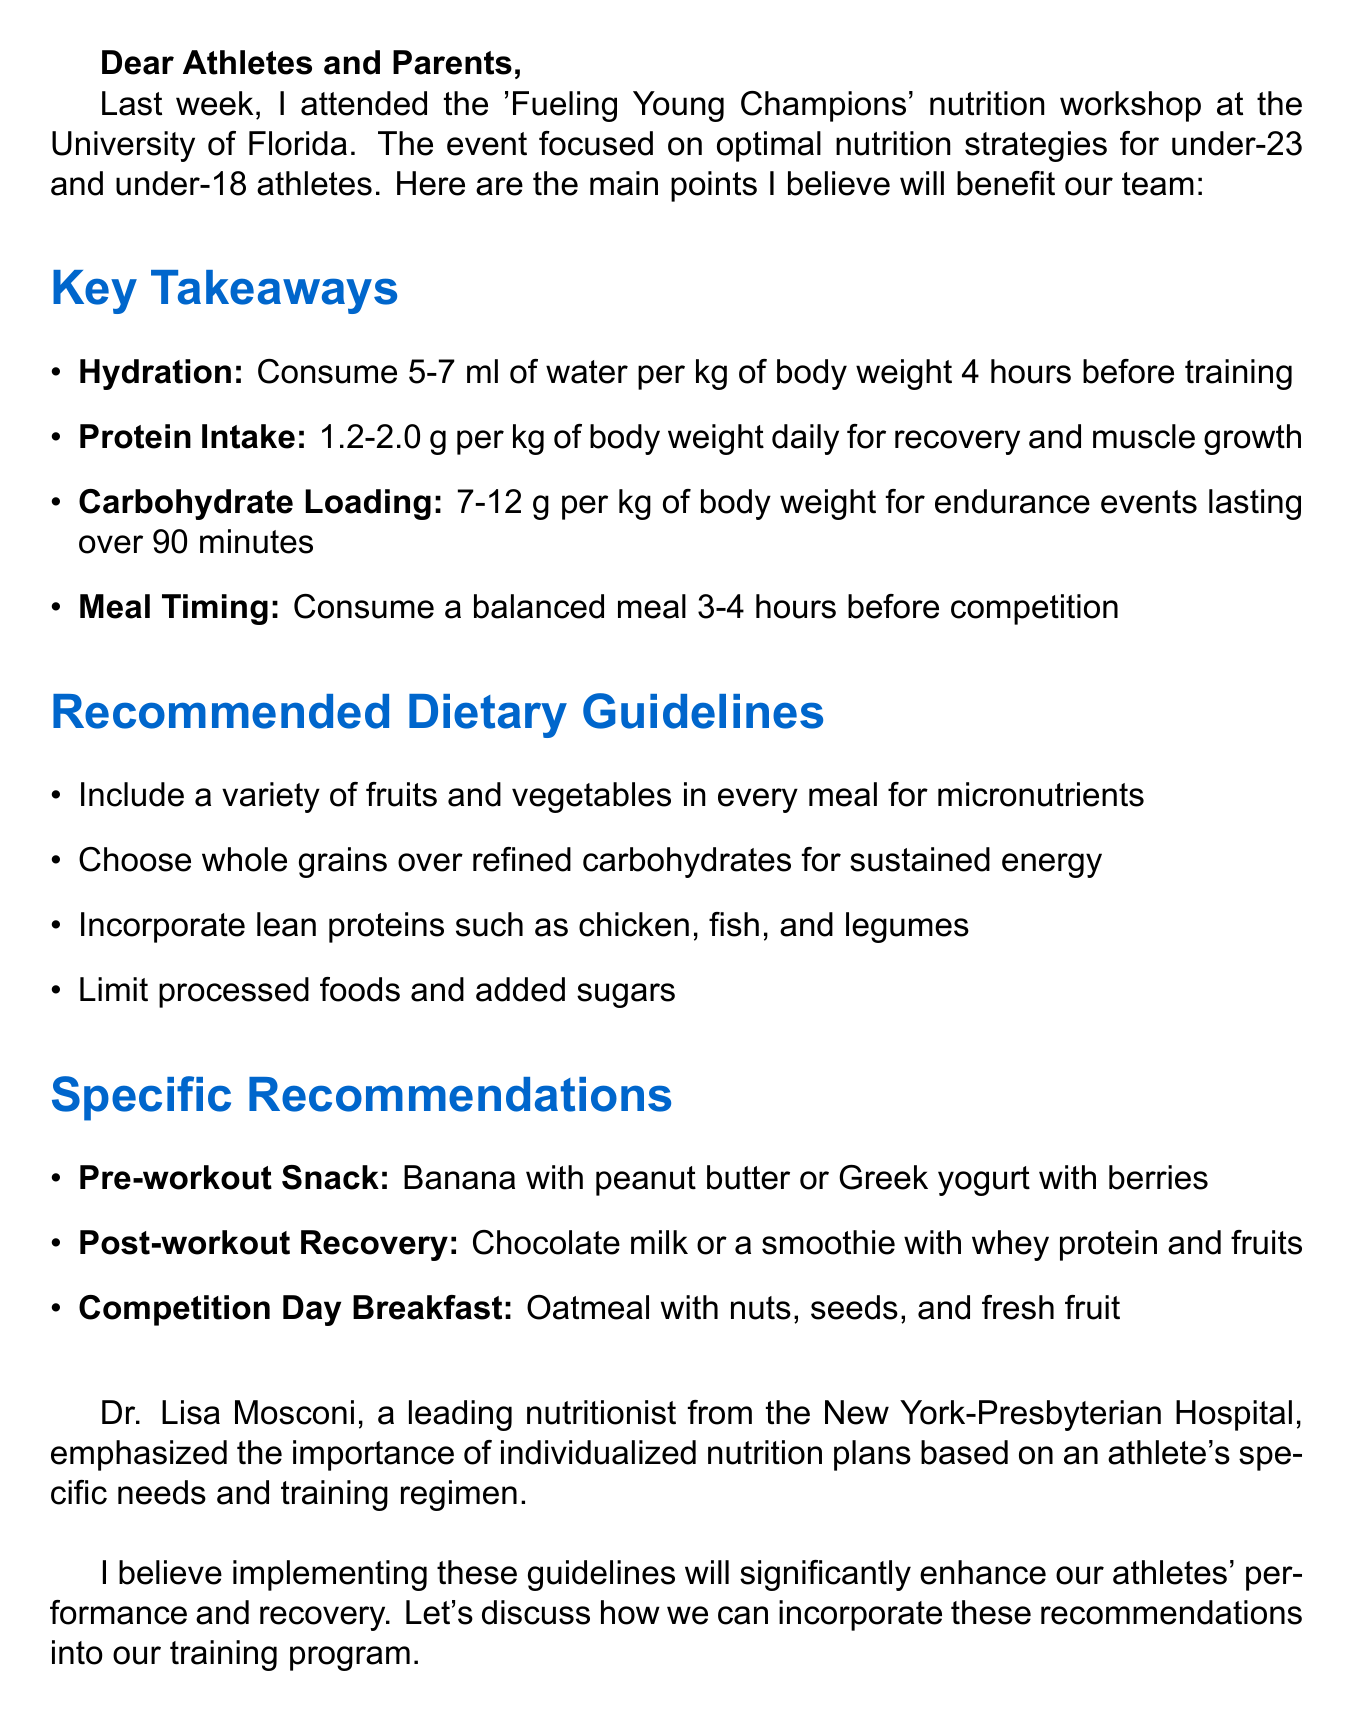What was the title of the workshop? The title of the workshop is 'Fueling Young Champions', which is mentioned in the introduction of the document.
Answer: Fueling Young Champions What institution hosted the workshop? The workshop was hosted at the University of Florida, as stated in the introduction.
Answer: University of Florida What is the recommended protein intake range? The document specifies the protein intake range for athletes is 1.2-2.0 g per kg of body weight daily for recovery and muscle growth.
Answer: 1.2-2.0 g per kg What is one of the specific recommendations for a pre-workout snack? The document mentions a banana with peanut butter or Greek yogurt with berries as a pre-workout snack.
Answer: Banana with peanut butter or Greek yogurt with berries Who provided expert advice at the workshop? The expert advice was provided by Dr. Lisa Mosconi, who is mentioned in the expert advice section.
Answer: Dr. Lisa Mosconi How many hours before training should athletes hydrate? Athletes should hydrate 4 hours before training, according to the key takeaways.
Answer: 4 hours What is emphasized regarding individualized nutrition? The importance of individualized nutrition plans based on an athlete's specific needs and training regimen is emphasized.
Answer: Individualized nutrition plans What should be included in every meal for micronutrients? The recommended dietary guidelines state that a variety of fruits and vegetables should be included in every meal for micronutrients.
Answer: Fruits and vegetables What is the recommended carbohydrate loading for endurance events? The document states the carbohydrate loading should be 7-12 g per kg of body weight for endurance events lasting over 90 minutes.
Answer: 7-12 g per kg 